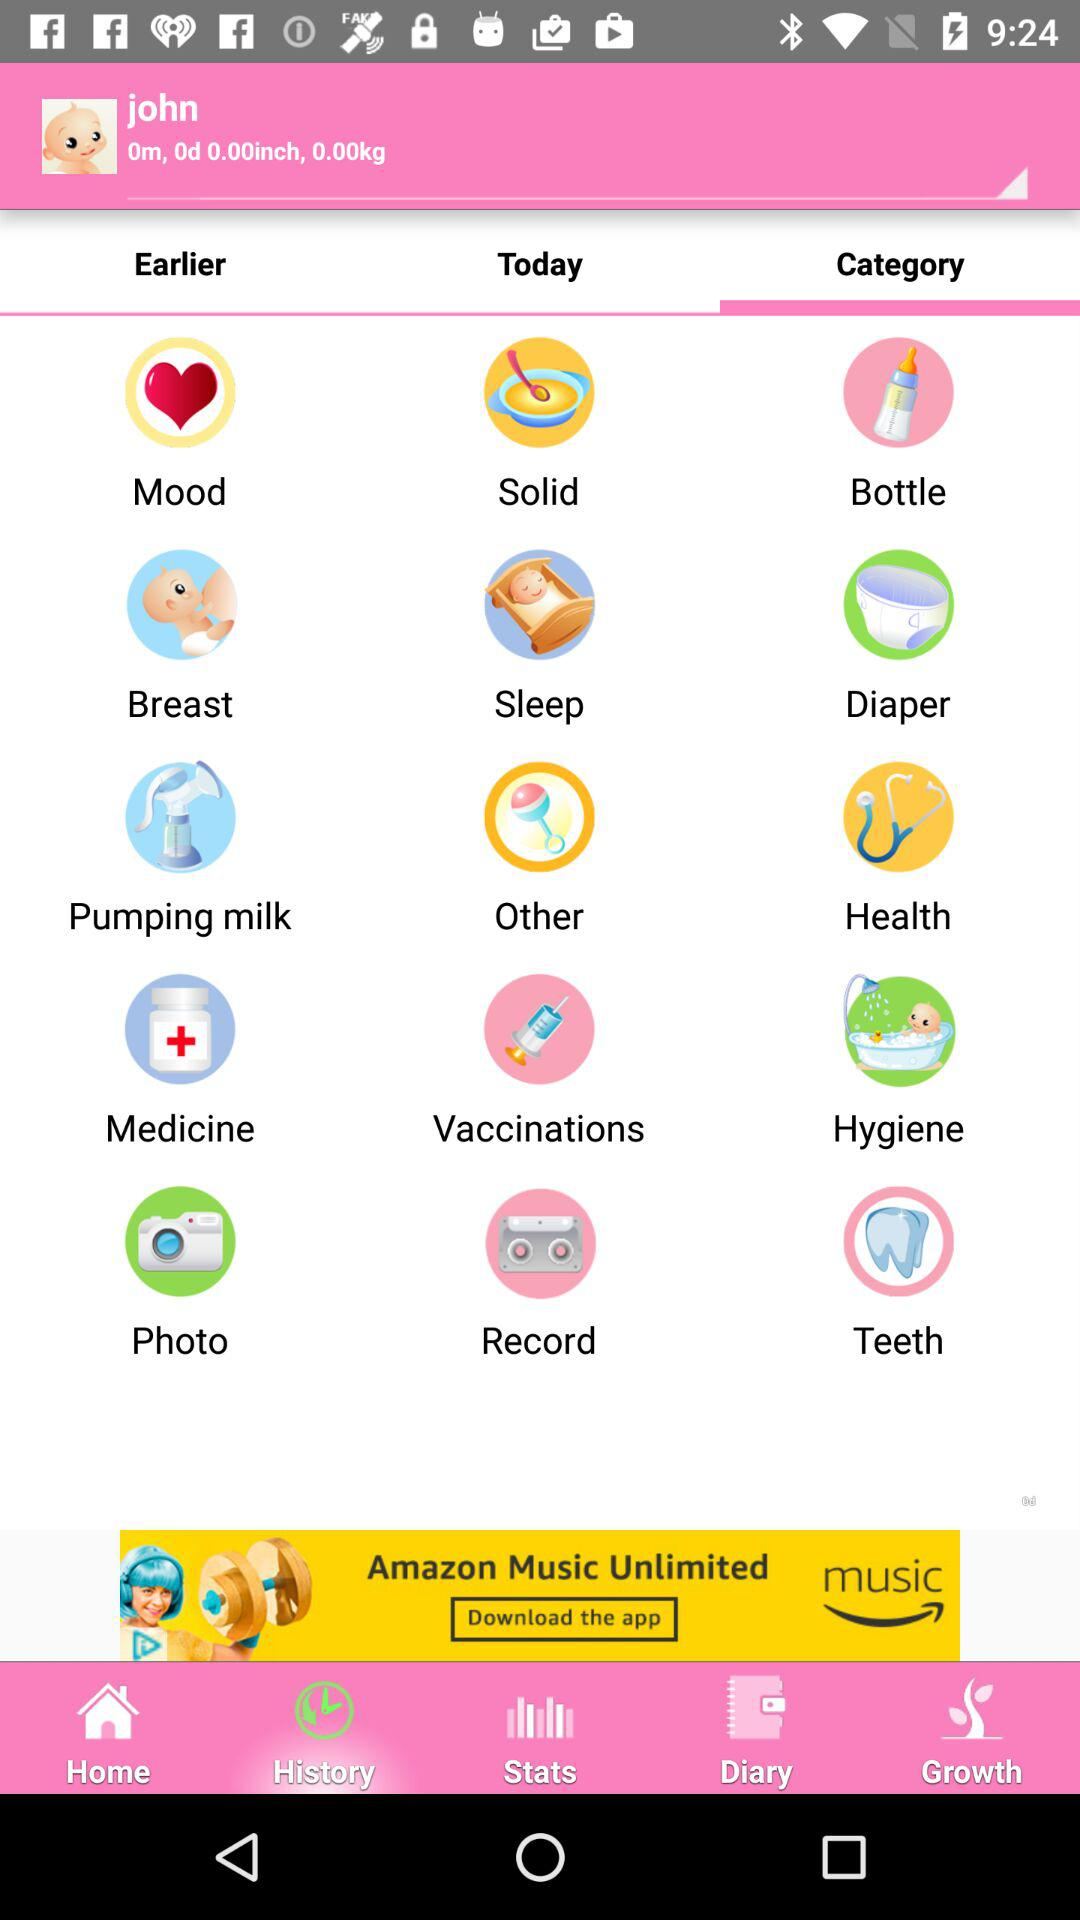What is the baby's name? The baby's name is John. 